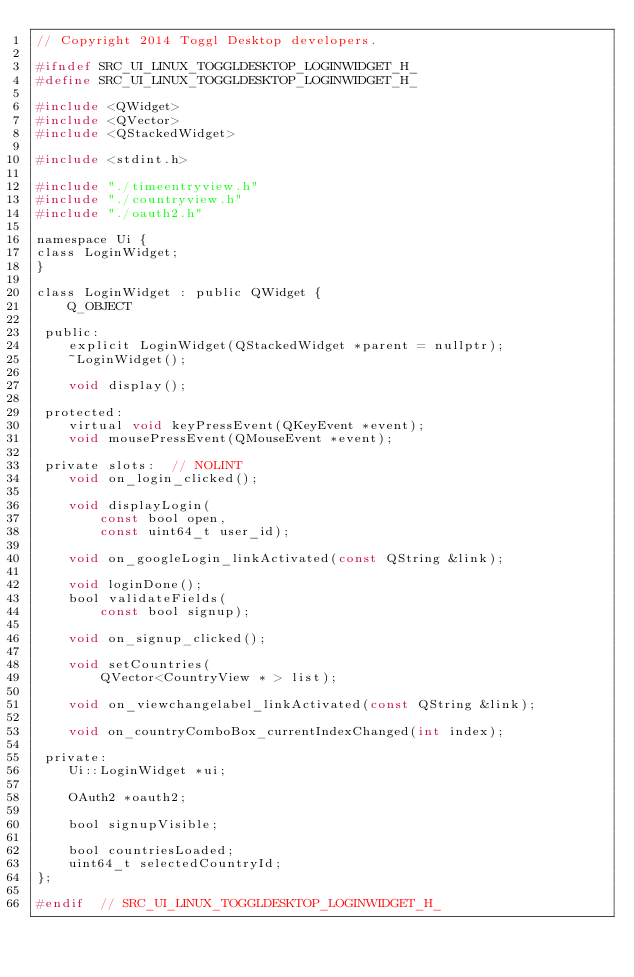<code> <loc_0><loc_0><loc_500><loc_500><_C_>// Copyright 2014 Toggl Desktop developers.

#ifndef SRC_UI_LINUX_TOGGLDESKTOP_LOGINWIDGET_H_
#define SRC_UI_LINUX_TOGGLDESKTOP_LOGINWIDGET_H_

#include <QWidget>
#include <QVector>
#include <QStackedWidget>

#include <stdint.h>

#include "./timeentryview.h"
#include "./countryview.h"
#include "./oauth2.h"

namespace Ui {
class LoginWidget;
}

class LoginWidget : public QWidget {
    Q_OBJECT

 public:
    explicit LoginWidget(QStackedWidget *parent = nullptr);
    ~LoginWidget();

    void display();

 protected:
    virtual void keyPressEvent(QKeyEvent *event);
    void mousePressEvent(QMouseEvent *event);

 private slots:  // NOLINT
    void on_login_clicked();

    void displayLogin(
        const bool open,
        const uint64_t user_id);

    void on_googleLogin_linkActivated(const QString &link);

    void loginDone();
    bool validateFields(
        const bool signup);

    void on_signup_clicked();

    void setCountries(
        QVector<CountryView * > list);

    void on_viewchangelabel_linkActivated(const QString &link);

    void on_countryComboBox_currentIndexChanged(int index);

 private:
    Ui::LoginWidget *ui;

    OAuth2 *oauth2;

    bool signupVisible;

    bool countriesLoaded;
    uint64_t selectedCountryId;
};

#endif  // SRC_UI_LINUX_TOGGLDESKTOP_LOGINWIDGET_H_
</code> 